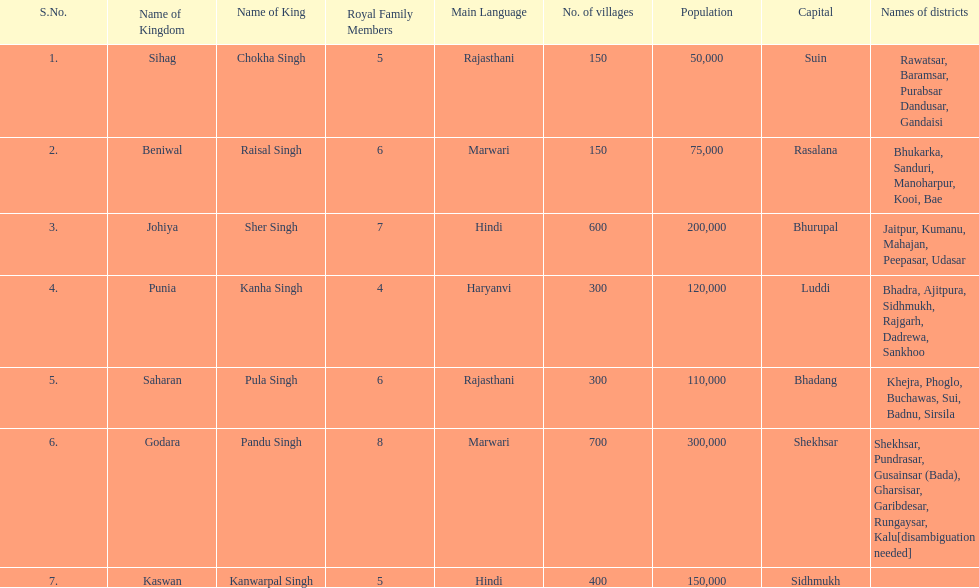Does punia have more or less villages than godara? Less. 